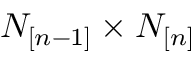Convert formula to latex. <formula><loc_0><loc_0><loc_500><loc_500>N _ { [ n - 1 ] } \times N _ { [ n ] }</formula> 